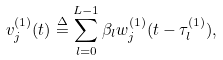Convert formula to latex. <formula><loc_0><loc_0><loc_500><loc_500>v ^ { ( 1 ) } _ { j } ( t ) \overset { \Delta } = \sum _ { l = 0 } ^ { L - 1 } \beta _ { l } w ^ { ( 1 ) } _ { j } ( t - \tau _ { l } ^ { ( 1 ) } ) ,</formula> 